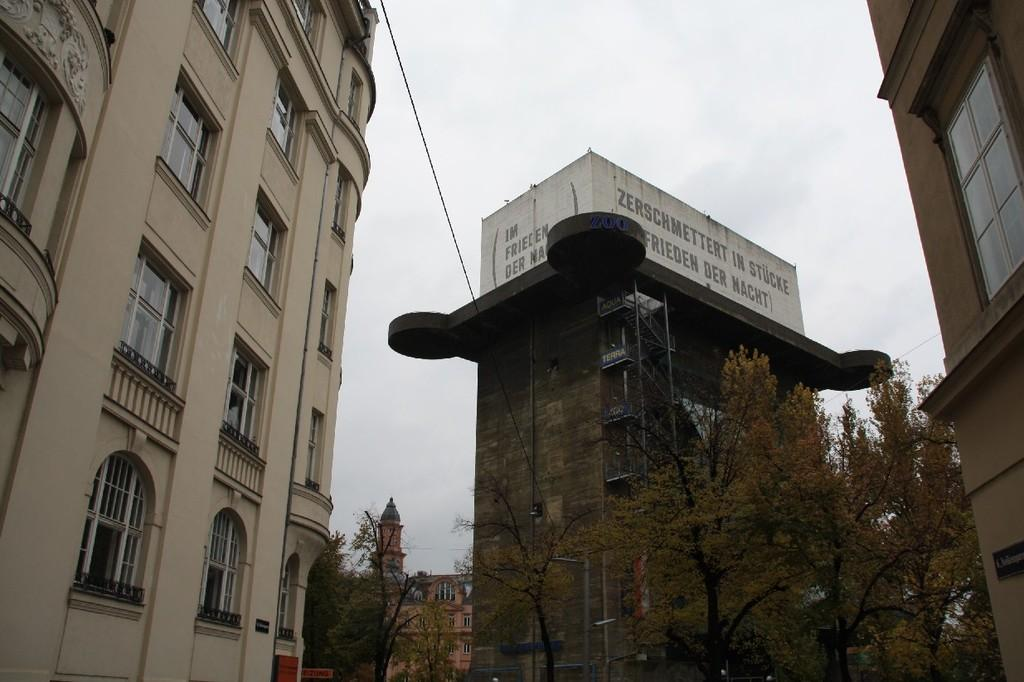What type of natural elements can be seen in the image? There are trees in the image. What type of man-made structures are present in the image? There are buildings with windows in the image. What is the purpose of the name board in the image? The name board in the image is likely used for identification or direction. What type of information can be found on the walls in the image? There are walls with text in the image, which may contain information, advertisements, or decorations. What architectural feature is present in the image? There are steps in the image. What can be seen in the background of the image? The sky is visible in the background of the image. Can you tell me how many insects are crawling on the skin of the person in the image? There is no person or insects present in the image; it features trees, buildings, a name board, walls with text, steps, and the sky. What type of mice can be seen playing with the text on the walls in the image? There are no mice present in the image; it features trees, buildings, a name board, walls with text, steps, and the sky. 